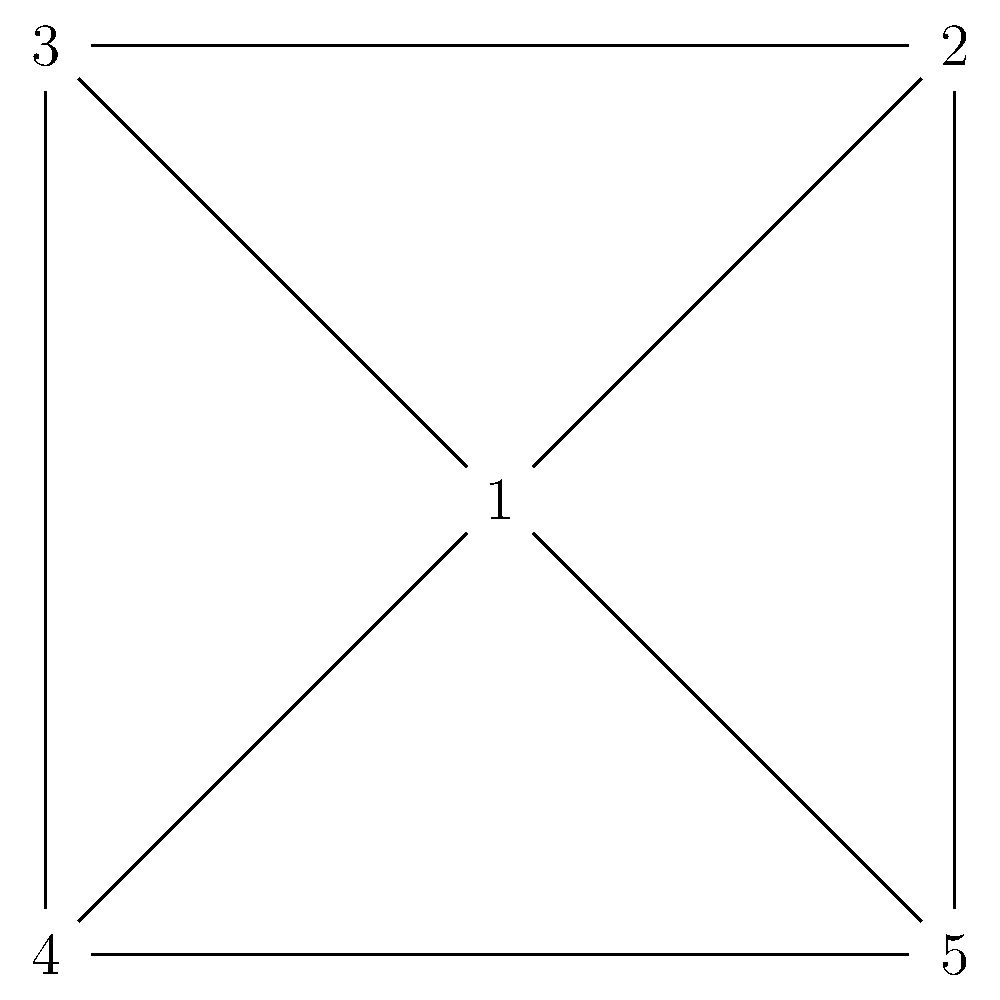As a psychologist managing a therapy practice, you need to schedule appointments for five clients who have conflicts with each other. The graph represents the conflicts, where each node is a client and an edge between two nodes indicates that those clients cannot be scheduled at the same time. What is the minimum number of time slots needed to schedule all appointments without conflicts? To solve this problem, we can use graph coloring theory:

1. Each color in the graph represents a time slot.
2. Adjacent vertices (connected by an edge) must have different colors, as they represent clients who cannot be scheduled at the same time.
3. The minimum number of colors needed to color the graph is called the chromatic number.

Let's color the graph step by step:

1. Start with client 1 (any vertex). Assign it color A.
2. Client 2 is connected to 1, so it needs a new color, B.
3. Client 3 is connected to both 1 and 2, so it needs a new color, C.
4. Client 4 is connected to 1, 2, and 3, so it needs a new color, D.
5. Client 5 is connected to all other clients, so it needs a new color, E.

We used 5 colors (A, B, C, D, E) in total, which is equal to the number of vertices in the graph. This is because the graph is a complete graph (all vertices are connected to each other).

In graph theory, a complete graph with $n$ vertices always has a chromatic number of $n$.

Therefore, the minimum number of time slots needed is 5.
Answer: 5 time slots 